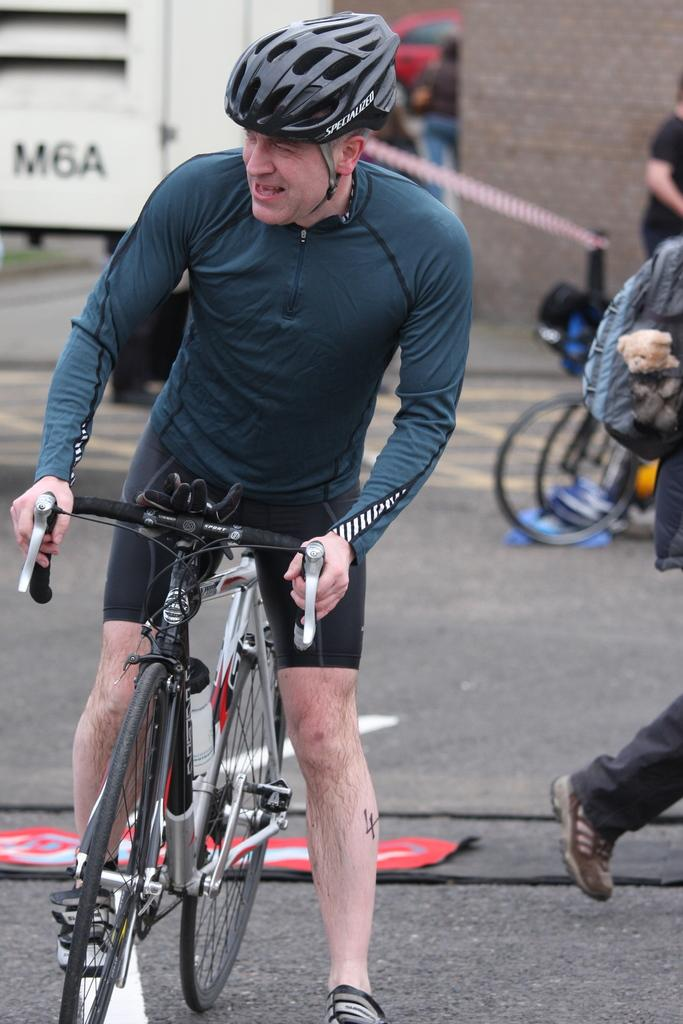Who is present in the image? There is a man in the image. What is the man wearing on his head? The man is wearing a helmet. What object is the man holding in the image? The man is holding a bicycle. What type of thrill can be seen on the actor's face in the image? There is no actor present in the image, and the man's face does not show any specific emotion related to a thrill. 